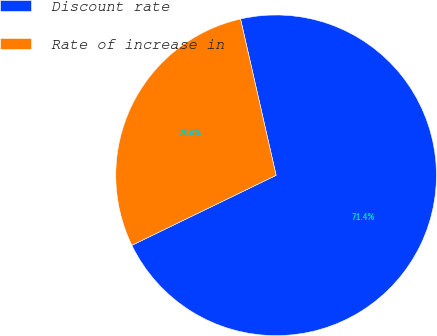Convert chart. <chart><loc_0><loc_0><loc_500><loc_500><pie_chart><fcel>Discount rate<fcel>Rate of increase in<nl><fcel>71.37%<fcel>28.63%<nl></chart> 